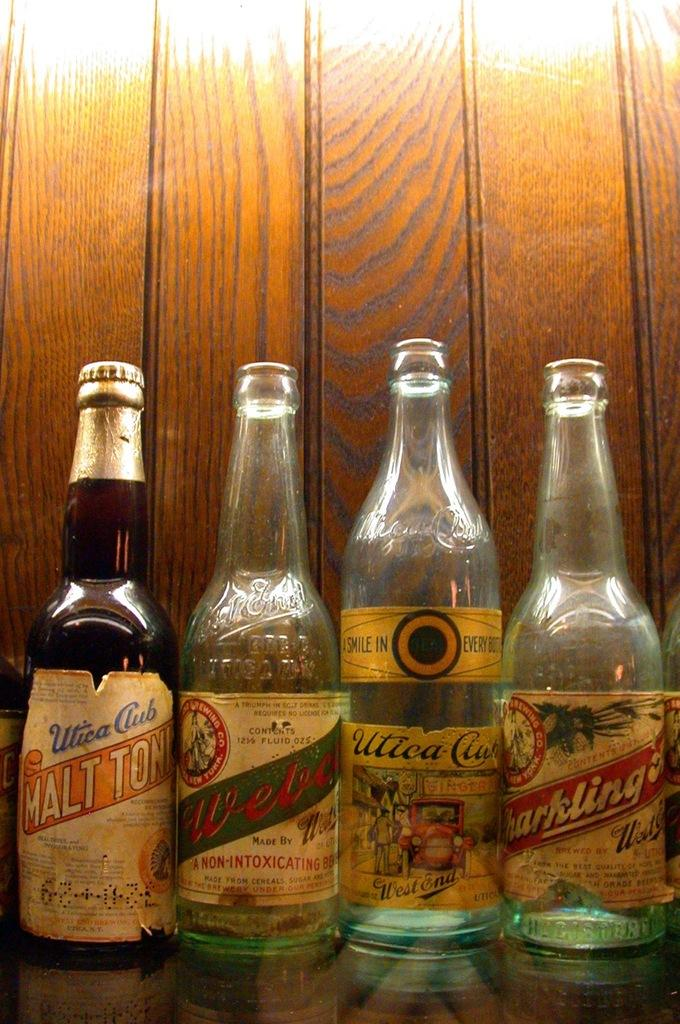<image>
Write a terse but informative summary of the picture. Vintage bottles of Utica Club a brown bottle with a gold cap 